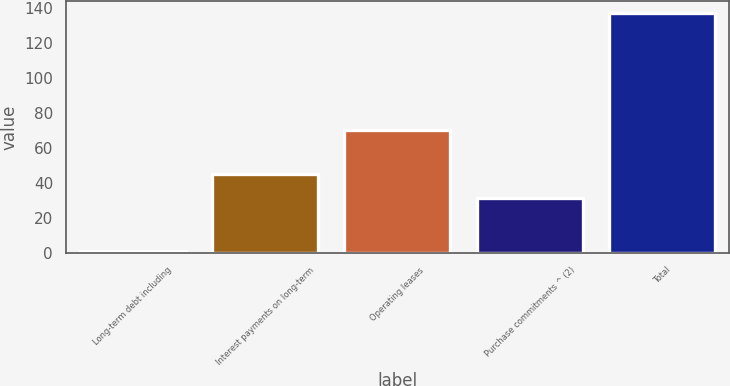Convert chart to OTSL. <chart><loc_0><loc_0><loc_500><loc_500><bar_chart><fcel>Long-term debt including<fcel>Interest payments on long-term<fcel>Operating leases<fcel>Purchase commitments ^ (2)<fcel>Total<nl><fcel>0.6<fcel>44.86<fcel>70.1<fcel>31.2<fcel>137.2<nl></chart> 